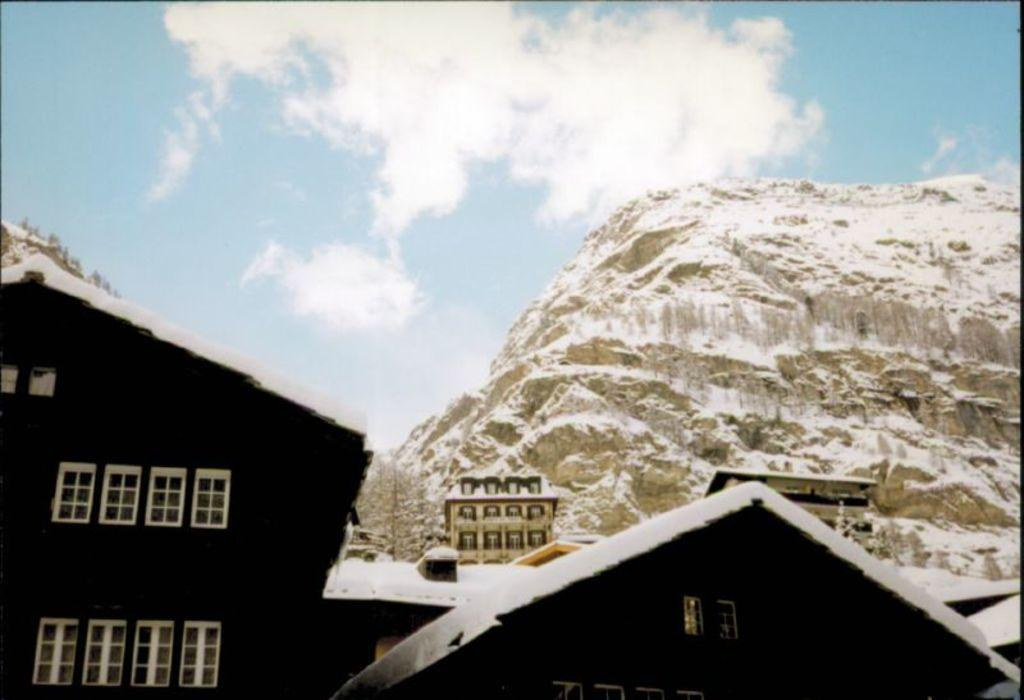What type of structures are present in the image? There are houses in the image. What feature do the houses have? The houses have windows. What can be seen in the background of the image? There is a hill and clouds visible in the background of the image. What else is visible in the background of the image? The sky is visible in the background of the image. Can you see any bubbles floating around the houses in the image? There are no bubbles present in the image; it features houses with windows, a hill, clouds, and the sky in the background. 